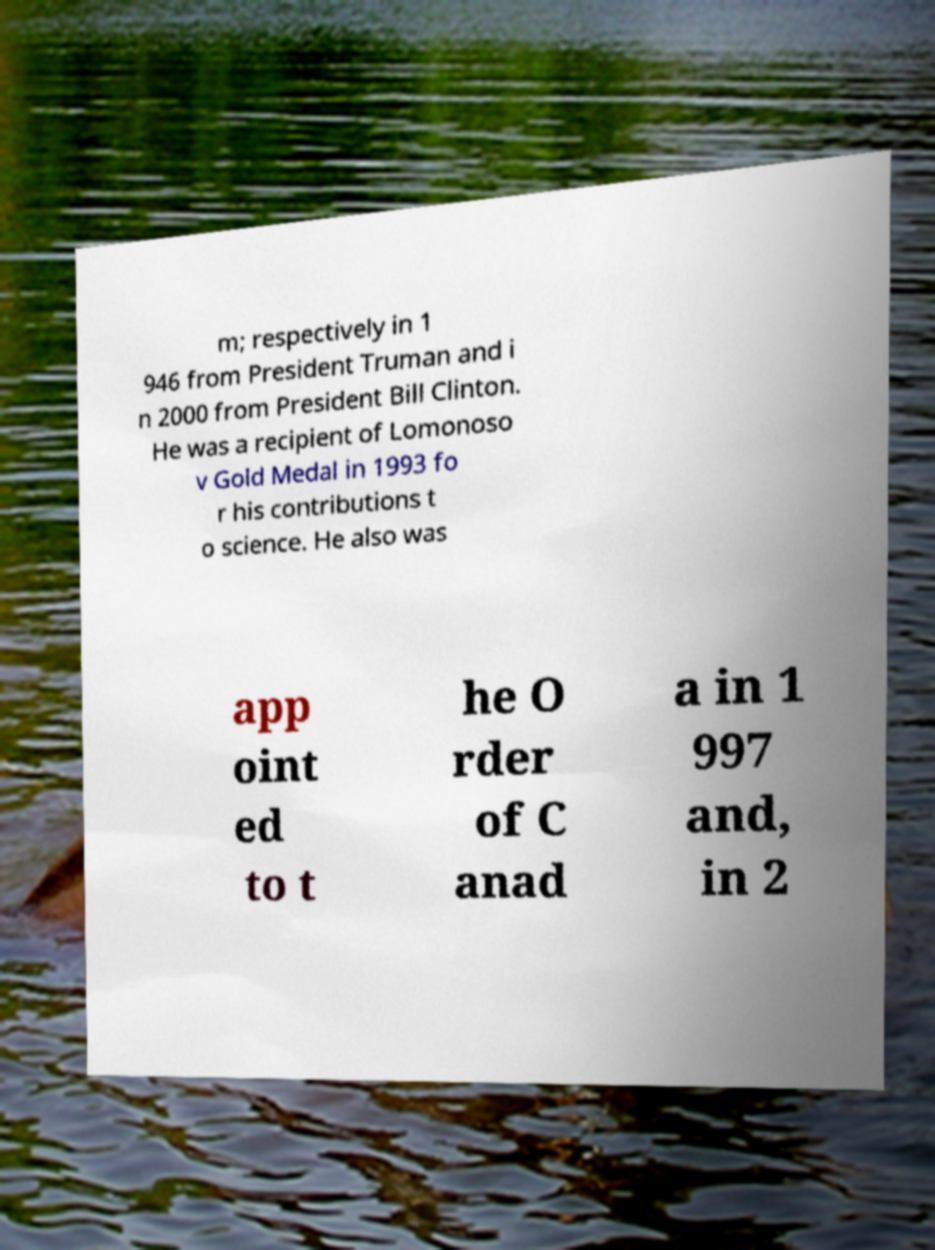Can you accurately transcribe the text from the provided image for me? m; respectively in 1 946 from President Truman and i n 2000 from President Bill Clinton. He was a recipient of Lomonoso v Gold Medal in 1993 fo r his contributions t o science. He also was app oint ed to t he O rder of C anad a in 1 997 and, in 2 